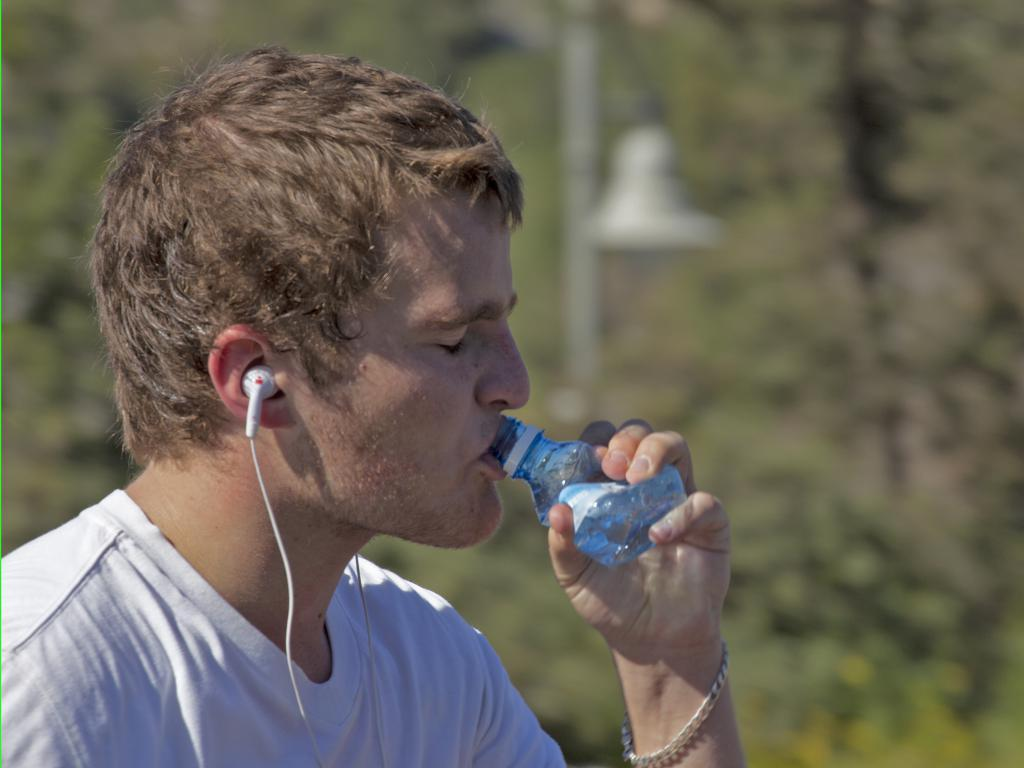Who is present in the image? There is a man in the image. What is the man wearing? The man is wearing a white t-shirt. What is the man doing in the image? The man is wearing earphones and drinking something. What can be seen in the background of the image? There are trees in the background of the image. What type of light is the man using to read in the image? There is no light visible in the image, and the man is not reading. 